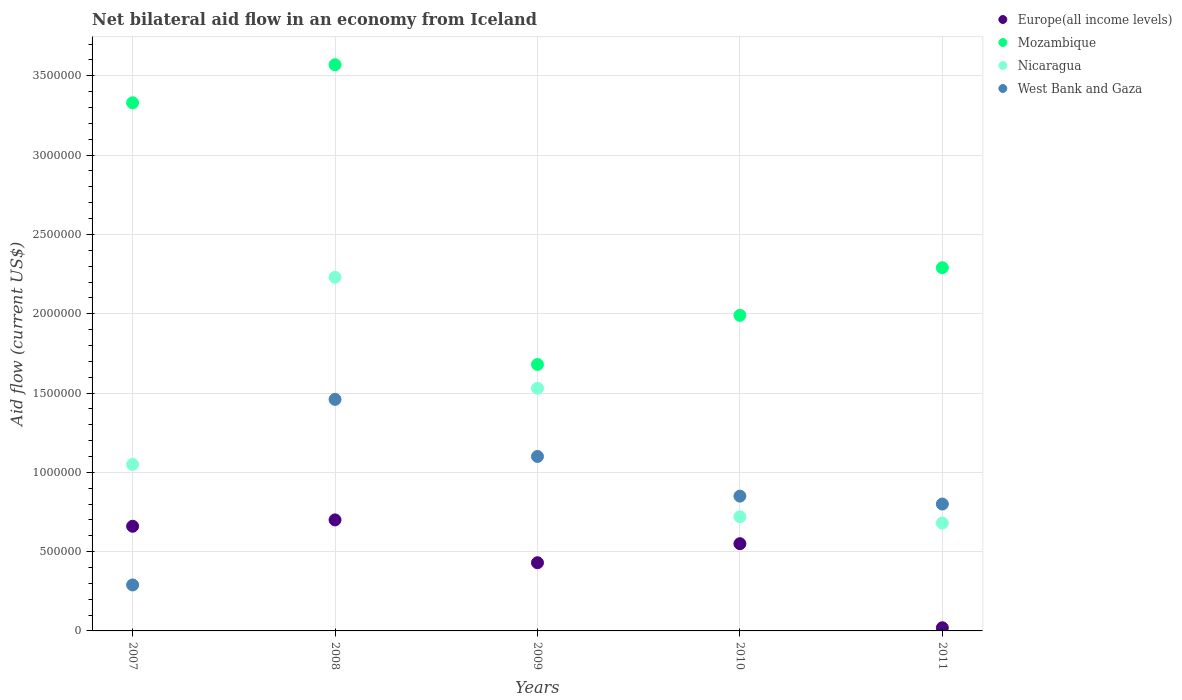What is the net bilateral aid flow in Nicaragua in 2008?
Make the answer very short. 2.23e+06. Across all years, what is the maximum net bilateral aid flow in Mozambique?
Provide a succinct answer. 3.57e+06. In which year was the net bilateral aid flow in West Bank and Gaza minimum?
Offer a terse response. 2007. What is the total net bilateral aid flow in Europe(all income levels) in the graph?
Your response must be concise. 2.36e+06. What is the difference between the net bilateral aid flow in Nicaragua in 2008 and that in 2010?
Provide a succinct answer. 1.51e+06. What is the difference between the net bilateral aid flow in West Bank and Gaza in 2011 and the net bilateral aid flow in Europe(all income levels) in 2010?
Provide a short and direct response. 2.50e+05. What is the average net bilateral aid flow in Europe(all income levels) per year?
Make the answer very short. 4.72e+05. In the year 2010, what is the difference between the net bilateral aid flow in West Bank and Gaza and net bilateral aid flow in Europe(all income levels)?
Give a very brief answer. 3.00e+05. In how many years, is the net bilateral aid flow in Europe(all income levels) greater than 3500000 US$?
Keep it short and to the point. 0. Is the difference between the net bilateral aid flow in West Bank and Gaza in 2007 and 2009 greater than the difference between the net bilateral aid flow in Europe(all income levels) in 2007 and 2009?
Keep it short and to the point. No. What is the difference between the highest and the second highest net bilateral aid flow in Nicaragua?
Offer a very short reply. 7.00e+05. What is the difference between the highest and the lowest net bilateral aid flow in Europe(all income levels)?
Ensure brevity in your answer.  6.80e+05. Is it the case that in every year, the sum of the net bilateral aid flow in Mozambique and net bilateral aid flow in Europe(all income levels)  is greater than the sum of net bilateral aid flow in West Bank and Gaza and net bilateral aid flow in Nicaragua?
Your answer should be very brief. Yes. Is the net bilateral aid flow in Europe(all income levels) strictly greater than the net bilateral aid flow in West Bank and Gaza over the years?
Ensure brevity in your answer.  No. Is the net bilateral aid flow in Nicaragua strictly less than the net bilateral aid flow in Mozambique over the years?
Offer a very short reply. Yes. How many dotlines are there?
Ensure brevity in your answer.  4. How many years are there in the graph?
Keep it short and to the point. 5. What is the difference between two consecutive major ticks on the Y-axis?
Your answer should be compact. 5.00e+05. Does the graph contain any zero values?
Give a very brief answer. No. Where does the legend appear in the graph?
Your answer should be compact. Top right. How many legend labels are there?
Ensure brevity in your answer.  4. How are the legend labels stacked?
Ensure brevity in your answer.  Vertical. What is the title of the graph?
Provide a short and direct response. Net bilateral aid flow in an economy from Iceland. What is the label or title of the Y-axis?
Provide a short and direct response. Aid flow (current US$). What is the Aid flow (current US$) of Mozambique in 2007?
Give a very brief answer. 3.33e+06. What is the Aid flow (current US$) in Nicaragua in 2007?
Your answer should be compact. 1.05e+06. What is the Aid flow (current US$) of West Bank and Gaza in 2007?
Make the answer very short. 2.90e+05. What is the Aid flow (current US$) in Mozambique in 2008?
Provide a succinct answer. 3.57e+06. What is the Aid flow (current US$) in Nicaragua in 2008?
Make the answer very short. 2.23e+06. What is the Aid flow (current US$) of West Bank and Gaza in 2008?
Your answer should be compact. 1.46e+06. What is the Aid flow (current US$) in Mozambique in 2009?
Provide a succinct answer. 1.68e+06. What is the Aid flow (current US$) in Nicaragua in 2009?
Offer a very short reply. 1.53e+06. What is the Aid flow (current US$) of West Bank and Gaza in 2009?
Your answer should be compact. 1.10e+06. What is the Aid flow (current US$) of Europe(all income levels) in 2010?
Make the answer very short. 5.50e+05. What is the Aid flow (current US$) in Mozambique in 2010?
Offer a terse response. 1.99e+06. What is the Aid flow (current US$) of Nicaragua in 2010?
Your answer should be compact. 7.20e+05. What is the Aid flow (current US$) in West Bank and Gaza in 2010?
Your response must be concise. 8.50e+05. What is the Aid flow (current US$) of Mozambique in 2011?
Make the answer very short. 2.29e+06. What is the Aid flow (current US$) of Nicaragua in 2011?
Provide a succinct answer. 6.80e+05. What is the Aid flow (current US$) of West Bank and Gaza in 2011?
Provide a short and direct response. 8.00e+05. Across all years, what is the maximum Aid flow (current US$) of Europe(all income levels)?
Give a very brief answer. 7.00e+05. Across all years, what is the maximum Aid flow (current US$) of Mozambique?
Your response must be concise. 3.57e+06. Across all years, what is the maximum Aid flow (current US$) in Nicaragua?
Offer a terse response. 2.23e+06. Across all years, what is the maximum Aid flow (current US$) of West Bank and Gaza?
Offer a very short reply. 1.46e+06. Across all years, what is the minimum Aid flow (current US$) in Mozambique?
Provide a succinct answer. 1.68e+06. Across all years, what is the minimum Aid flow (current US$) in Nicaragua?
Your response must be concise. 6.80e+05. Across all years, what is the minimum Aid flow (current US$) in West Bank and Gaza?
Keep it short and to the point. 2.90e+05. What is the total Aid flow (current US$) of Europe(all income levels) in the graph?
Give a very brief answer. 2.36e+06. What is the total Aid flow (current US$) in Mozambique in the graph?
Give a very brief answer. 1.29e+07. What is the total Aid flow (current US$) of Nicaragua in the graph?
Ensure brevity in your answer.  6.21e+06. What is the total Aid flow (current US$) of West Bank and Gaza in the graph?
Offer a terse response. 4.50e+06. What is the difference between the Aid flow (current US$) in Mozambique in 2007 and that in 2008?
Your answer should be compact. -2.40e+05. What is the difference between the Aid flow (current US$) in Nicaragua in 2007 and that in 2008?
Ensure brevity in your answer.  -1.18e+06. What is the difference between the Aid flow (current US$) in West Bank and Gaza in 2007 and that in 2008?
Offer a very short reply. -1.17e+06. What is the difference between the Aid flow (current US$) in Europe(all income levels) in 2007 and that in 2009?
Your response must be concise. 2.30e+05. What is the difference between the Aid flow (current US$) in Mozambique in 2007 and that in 2009?
Ensure brevity in your answer.  1.65e+06. What is the difference between the Aid flow (current US$) in Nicaragua in 2007 and that in 2009?
Your answer should be compact. -4.80e+05. What is the difference between the Aid flow (current US$) in West Bank and Gaza in 2007 and that in 2009?
Make the answer very short. -8.10e+05. What is the difference between the Aid flow (current US$) in Europe(all income levels) in 2007 and that in 2010?
Provide a succinct answer. 1.10e+05. What is the difference between the Aid flow (current US$) of Mozambique in 2007 and that in 2010?
Make the answer very short. 1.34e+06. What is the difference between the Aid flow (current US$) of West Bank and Gaza in 2007 and that in 2010?
Offer a very short reply. -5.60e+05. What is the difference between the Aid flow (current US$) in Europe(all income levels) in 2007 and that in 2011?
Offer a very short reply. 6.40e+05. What is the difference between the Aid flow (current US$) in Mozambique in 2007 and that in 2011?
Offer a terse response. 1.04e+06. What is the difference between the Aid flow (current US$) in Nicaragua in 2007 and that in 2011?
Keep it short and to the point. 3.70e+05. What is the difference between the Aid flow (current US$) in West Bank and Gaza in 2007 and that in 2011?
Make the answer very short. -5.10e+05. What is the difference between the Aid flow (current US$) in Mozambique in 2008 and that in 2009?
Offer a terse response. 1.89e+06. What is the difference between the Aid flow (current US$) of Mozambique in 2008 and that in 2010?
Provide a succinct answer. 1.58e+06. What is the difference between the Aid flow (current US$) of Nicaragua in 2008 and that in 2010?
Provide a short and direct response. 1.51e+06. What is the difference between the Aid flow (current US$) of West Bank and Gaza in 2008 and that in 2010?
Ensure brevity in your answer.  6.10e+05. What is the difference between the Aid flow (current US$) in Europe(all income levels) in 2008 and that in 2011?
Offer a very short reply. 6.80e+05. What is the difference between the Aid flow (current US$) in Mozambique in 2008 and that in 2011?
Ensure brevity in your answer.  1.28e+06. What is the difference between the Aid flow (current US$) of Nicaragua in 2008 and that in 2011?
Ensure brevity in your answer.  1.55e+06. What is the difference between the Aid flow (current US$) of West Bank and Gaza in 2008 and that in 2011?
Your answer should be compact. 6.60e+05. What is the difference between the Aid flow (current US$) in Mozambique in 2009 and that in 2010?
Give a very brief answer. -3.10e+05. What is the difference between the Aid flow (current US$) of Nicaragua in 2009 and that in 2010?
Provide a short and direct response. 8.10e+05. What is the difference between the Aid flow (current US$) of Mozambique in 2009 and that in 2011?
Provide a succinct answer. -6.10e+05. What is the difference between the Aid flow (current US$) in Nicaragua in 2009 and that in 2011?
Make the answer very short. 8.50e+05. What is the difference between the Aid flow (current US$) in West Bank and Gaza in 2009 and that in 2011?
Your answer should be very brief. 3.00e+05. What is the difference between the Aid flow (current US$) in Europe(all income levels) in 2010 and that in 2011?
Your answer should be very brief. 5.30e+05. What is the difference between the Aid flow (current US$) of Mozambique in 2010 and that in 2011?
Ensure brevity in your answer.  -3.00e+05. What is the difference between the Aid flow (current US$) in Nicaragua in 2010 and that in 2011?
Offer a very short reply. 4.00e+04. What is the difference between the Aid flow (current US$) in West Bank and Gaza in 2010 and that in 2011?
Offer a very short reply. 5.00e+04. What is the difference between the Aid flow (current US$) of Europe(all income levels) in 2007 and the Aid flow (current US$) of Mozambique in 2008?
Your answer should be very brief. -2.91e+06. What is the difference between the Aid flow (current US$) of Europe(all income levels) in 2007 and the Aid flow (current US$) of Nicaragua in 2008?
Your answer should be very brief. -1.57e+06. What is the difference between the Aid flow (current US$) of Europe(all income levels) in 2007 and the Aid flow (current US$) of West Bank and Gaza in 2008?
Offer a terse response. -8.00e+05. What is the difference between the Aid flow (current US$) of Mozambique in 2007 and the Aid flow (current US$) of Nicaragua in 2008?
Give a very brief answer. 1.10e+06. What is the difference between the Aid flow (current US$) in Mozambique in 2007 and the Aid flow (current US$) in West Bank and Gaza in 2008?
Your answer should be very brief. 1.87e+06. What is the difference between the Aid flow (current US$) of Nicaragua in 2007 and the Aid flow (current US$) of West Bank and Gaza in 2008?
Keep it short and to the point. -4.10e+05. What is the difference between the Aid flow (current US$) in Europe(all income levels) in 2007 and the Aid flow (current US$) in Mozambique in 2009?
Offer a very short reply. -1.02e+06. What is the difference between the Aid flow (current US$) of Europe(all income levels) in 2007 and the Aid flow (current US$) of Nicaragua in 2009?
Keep it short and to the point. -8.70e+05. What is the difference between the Aid flow (current US$) of Europe(all income levels) in 2007 and the Aid flow (current US$) of West Bank and Gaza in 2009?
Offer a terse response. -4.40e+05. What is the difference between the Aid flow (current US$) in Mozambique in 2007 and the Aid flow (current US$) in Nicaragua in 2009?
Your answer should be very brief. 1.80e+06. What is the difference between the Aid flow (current US$) of Mozambique in 2007 and the Aid flow (current US$) of West Bank and Gaza in 2009?
Your response must be concise. 2.23e+06. What is the difference between the Aid flow (current US$) in Europe(all income levels) in 2007 and the Aid flow (current US$) in Mozambique in 2010?
Keep it short and to the point. -1.33e+06. What is the difference between the Aid flow (current US$) of Europe(all income levels) in 2007 and the Aid flow (current US$) of West Bank and Gaza in 2010?
Make the answer very short. -1.90e+05. What is the difference between the Aid flow (current US$) of Mozambique in 2007 and the Aid flow (current US$) of Nicaragua in 2010?
Keep it short and to the point. 2.61e+06. What is the difference between the Aid flow (current US$) of Mozambique in 2007 and the Aid flow (current US$) of West Bank and Gaza in 2010?
Your answer should be very brief. 2.48e+06. What is the difference between the Aid flow (current US$) in Europe(all income levels) in 2007 and the Aid flow (current US$) in Mozambique in 2011?
Keep it short and to the point. -1.63e+06. What is the difference between the Aid flow (current US$) of Europe(all income levels) in 2007 and the Aid flow (current US$) of West Bank and Gaza in 2011?
Provide a succinct answer. -1.40e+05. What is the difference between the Aid flow (current US$) in Mozambique in 2007 and the Aid flow (current US$) in Nicaragua in 2011?
Give a very brief answer. 2.65e+06. What is the difference between the Aid flow (current US$) in Mozambique in 2007 and the Aid flow (current US$) in West Bank and Gaza in 2011?
Your answer should be very brief. 2.53e+06. What is the difference between the Aid flow (current US$) of Europe(all income levels) in 2008 and the Aid flow (current US$) of Mozambique in 2009?
Your response must be concise. -9.80e+05. What is the difference between the Aid flow (current US$) of Europe(all income levels) in 2008 and the Aid flow (current US$) of Nicaragua in 2009?
Offer a terse response. -8.30e+05. What is the difference between the Aid flow (current US$) in Europe(all income levels) in 2008 and the Aid flow (current US$) in West Bank and Gaza in 2009?
Give a very brief answer. -4.00e+05. What is the difference between the Aid flow (current US$) of Mozambique in 2008 and the Aid flow (current US$) of Nicaragua in 2009?
Ensure brevity in your answer.  2.04e+06. What is the difference between the Aid flow (current US$) in Mozambique in 2008 and the Aid flow (current US$) in West Bank and Gaza in 2009?
Provide a short and direct response. 2.47e+06. What is the difference between the Aid flow (current US$) of Nicaragua in 2008 and the Aid flow (current US$) of West Bank and Gaza in 2009?
Provide a succinct answer. 1.13e+06. What is the difference between the Aid flow (current US$) in Europe(all income levels) in 2008 and the Aid flow (current US$) in Mozambique in 2010?
Provide a succinct answer. -1.29e+06. What is the difference between the Aid flow (current US$) of Europe(all income levels) in 2008 and the Aid flow (current US$) of Nicaragua in 2010?
Give a very brief answer. -2.00e+04. What is the difference between the Aid flow (current US$) in Europe(all income levels) in 2008 and the Aid flow (current US$) in West Bank and Gaza in 2010?
Keep it short and to the point. -1.50e+05. What is the difference between the Aid flow (current US$) in Mozambique in 2008 and the Aid flow (current US$) in Nicaragua in 2010?
Provide a short and direct response. 2.85e+06. What is the difference between the Aid flow (current US$) of Mozambique in 2008 and the Aid flow (current US$) of West Bank and Gaza in 2010?
Offer a terse response. 2.72e+06. What is the difference between the Aid flow (current US$) of Nicaragua in 2008 and the Aid flow (current US$) of West Bank and Gaza in 2010?
Keep it short and to the point. 1.38e+06. What is the difference between the Aid flow (current US$) in Europe(all income levels) in 2008 and the Aid flow (current US$) in Mozambique in 2011?
Keep it short and to the point. -1.59e+06. What is the difference between the Aid flow (current US$) in Europe(all income levels) in 2008 and the Aid flow (current US$) in Nicaragua in 2011?
Offer a terse response. 2.00e+04. What is the difference between the Aid flow (current US$) of Europe(all income levels) in 2008 and the Aid flow (current US$) of West Bank and Gaza in 2011?
Provide a short and direct response. -1.00e+05. What is the difference between the Aid flow (current US$) in Mozambique in 2008 and the Aid flow (current US$) in Nicaragua in 2011?
Your answer should be compact. 2.89e+06. What is the difference between the Aid flow (current US$) in Mozambique in 2008 and the Aid flow (current US$) in West Bank and Gaza in 2011?
Your answer should be compact. 2.77e+06. What is the difference between the Aid flow (current US$) in Nicaragua in 2008 and the Aid flow (current US$) in West Bank and Gaza in 2011?
Offer a very short reply. 1.43e+06. What is the difference between the Aid flow (current US$) of Europe(all income levels) in 2009 and the Aid flow (current US$) of Mozambique in 2010?
Make the answer very short. -1.56e+06. What is the difference between the Aid flow (current US$) of Europe(all income levels) in 2009 and the Aid flow (current US$) of Nicaragua in 2010?
Provide a short and direct response. -2.90e+05. What is the difference between the Aid flow (current US$) of Europe(all income levels) in 2009 and the Aid flow (current US$) of West Bank and Gaza in 2010?
Keep it short and to the point. -4.20e+05. What is the difference between the Aid flow (current US$) of Mozambique in 2009 and the Aid flow (current US$) of Nicaragua in 2010?
Make the answer very short. 9.60e+05. What is the difference between the Aid flow (current US$) in Mozambique in 2009 and the Aid flow (current US$) in West Bank and Gaza in 2010?
Your response must be concise. 8.30e+05. What is the difference between the Aid flow (current US$) in Nicaragua in 2009 and the Aid flow (current US$) in West Bank and Gaza in 2010?
Ensure brevity in your answer.  6.80e+05. What is the difference between the Aid flow (current US$) of Europe(all income levels) in 2009 and the Aid flow (current US$) of Mozambique in 2011?
Offer a very short reply. -1.86e+06. What is the difference between the Aid flow (current US$) in Europe(all income levels) in 2009 and the Aid flow (current US$) in Nicaragua in 2011?
Provide a short and direct response. -2.50e+05. What is the difference between the Aid flow (current US$) in Europe(all income levels) in 2009 and the Aid flow (current US$) in West Bank and Gaza in 2011?
Ensure brevity in your answer.  -3.70e+05. What is the difference between the Aid flow (current US$) in Mozambique in 2009 and the Aid flow (current US$) in West Bank and Gaza in 2011?
Your answer should be compact. 8.80e+05. What is the difference between the Aid flow (current US$) of Nicaragua in 2009 and the Aid flow (current US$) of West Bank and Gaza in 2011?
Give a very brief answer. 7.30e+05. What is the difference between the Aid flow (current US$) in Europe(all income levels) in 2010 and the Aid flow (current US$) in Mozambique in 2011?
Your response must be concise. -1.74e+06. What is the difference between the Aid flow (current US$) in Mozambique in 2010 and the Aid flow (current US$) in Nicaragua in 2011?
Keep it short and to the point. 1.31e+06. What is the difference between the Aid flow (current US$) in Mozambique in 2010 and the Aid flow (current US$) in West Bank and Gaza in 2011?
Offer a very short reply. 1.19e+06. What is the difference between the Aid flow (current US$) of Nicaragua in 2010 and the Aid flow (current US$) of West Bank and Gaza in 2011?
Your answer should be compact. -8.00e+04. What is the average Aid flow (current US$) in Europe(all income levels) per year?
Keep it short and to the point. 4.72e+05. What is the average Aid flow (current US$) of Mozambique per year?
Ensure brevity in your answer.  2.57e+06. What is the average Aid flow (current US$) in Nicaragua per year?
Ensure brevity in your answer.  1.24e+06. What is the average Aid flow (current US$) of West Bank and Gaza per year?
Offer a terse response. 9.00e+05. In the year 2007, what is the difference between the Aid flow (current US$) of Europe(all income levels) and Aid flow (current US$) of Mozambique?
Ensure brevity in your answer.  -2.67e+06. In the year 2007, what is the difference between the Aid flow (current US$) in Europe(all income levels) and Aid flow (current US$) in Nicaragua?
Give a very brief answer. -3.90e+05. In the year 2007, what is the difference between the Aid flow (current US$) in Mozambique and Aid flow (current US$) in Nicaragua?
Your answer should be compact. 2.28e+06. In the year 2007, what is the difference between the Aid flow (current US$) of Mozambique and Aid flow (current US$) of West Bank and Gaza?
Give a very brief answer. 3.04e+06. In the year 2007, what is the difference between the Aid flow (current US$) of Nicaragua and Aid flow (current US$) of West Bank and Gaza?
Offer a terse response. 7.60e+05. In the year 2008, what is the difference between the Aid flow (current US$) of Europe(all income levels) and Aid flow (current US$) of Mozambique?
Your answer should be compact. -2.87e+06. In the year 2008, what is the difference between the Aid flow (current US$) of Europe(all income levels) and Aid flow (current US$) of Nicaragua?
Give a very brief answer. -1.53e+06. In the year 2008, what is the difference between the Aid flow (current US$) of Europe(all income levels) and Aid flow (current US$) of West Bank and Gaza?
Make the answer very short. -7.60e+05. In the year 2008, what is the difference between the Aid flow (current US$) in Mozambique and Aid flow (current US$) in Nicaragua?
Give a very brief answer. 1.34e+06. In the year 2008, what is the difference between the Aid flow (current US$) in Mozambique and Aid flow (current US$) in West Bank and Gaza?
Provide a short and direct response. 2.11e+06. In the year 2008, what is the difference between the Aid flow (current US$) in Nicaragua and Aid flow (current US$) in West Bank and Gaza?
Make the answer very short. 7.70e+05. In the year 2009, what is the difference between the Aid flow (current US$) in Europe(all income levels) and Aid flow (current US$) in Mozambique?
Your response must be concise. -1.25e+06. In the year 2009, what is the difference between the Aid flow (current US$) in Europe(all income levels) and Aid flow (current US$) in Nicaragua?
Ensure brevity in your answer.  -1.10e+06. In the year 2009, what is the difference between the Aid flow (current US$) of Europe(all income levels) and Aid flow (current US$) of West Bank and Gaza?
Your response must be concise. -6.70e+05. In the year 2009, what is the difference between the Aid flow (current US$) in Mozambique and Aid flow (current US$) in West Bank and Gaza?
Ensure brevity in your answer.  5.80e+05. In the year 2009, what is the difference between the Aid flow (current US$) in Nicaragua and Aid flow (current US$) in West Bank and Gaza?
Offer a very short reply. 4.30e+05. In the year 2010, what is the difference between the Aid flow (current US$) in Europe(all income levels) and Aid flow (current US$) in Mozambique?
Make the answer very short. -1.44e+06. In the year 2010, what is the difference between the Aid flow (current US$) in Mozambique and Aid flow (current US$) in Nicaragua?
Offer a terse response. 1.27e+06. In the year 2010, what is the difference between the Aid flow (current US$) of Mozambique and Aid flow (current US$) of West Bank and Gaza?
Ensure brevity in your answer.  1.14e+06. In the year 2010, what is the difference between the Aid flow (current US$) of Nicaragua and Aid flow (current US$) of West Bank and Gaza?
Ensure brevity in your answer.  -1.30e+05. In the year 2011, what is the difference between the Aid flow (current US$) in Europe(all income levels) and Aid flow (current US$) in Mozambique?
Give a very brief answer. -2.27e+06. In the year 2011, what is the difference between the Aid flow (current US$) in Europe(all income levels) and Aid flow (current US$) in Nicaragua?
Give a very brief answer. -6.60e+05. In the year 2011, what is the difference between the Aid flow (current US$) of Europe(all income levels) and Aid flow (current US$) of West Bank and Gaza?
Ensure brevity in your answer.  -7.80e+05. In the year 2011, what is the difference between the Aid flow (current US$) of Mozambique and Aid flow (current US$) of Nicaragua?
Give a very brief answer. 1.61e+06. In the year 2011, what is the difference between the Aid flow (current US$) in Mozambique and Aid flow (current US$) in West Bank and Gaza?
Your response must be concise. 1.49e+06. In the year 2011, what is the difference between the Aid flow (current US$) of Nicaragua and Aid flow (current US$) of West Bank and Gaza?
Your answer should be compact. -1.20e+05. What is the ratio of the Aid flow (current US$) of Europe(all income levels) in 2007 to that in 2008?
Offer a very short reply. 0.94. What is the ratio of the Aid flow (current US$) of Mozambique in 2007 to that in 2008?
Ensure brevity in your answer.  0.93. What is the ratio of the Aid flow (current US$) in Nicaragua in 2007 to that in 2008?
Keep it short and to the point. 0.47. What is the ratio of the Aid flow (current US$) of West Bank and Gaza in 2007 to that in 2008?
Keep it short and to the point. 0.2. What is the ratio of the Aid flow (current US$) of Europe(all income levels) in 2007 to that in 2009?
Keep it short and to the point. 1.53. What is the ratio of the Aid flow (current US$) in Mozambique in 2007 to that in 2009?
Your answer should be compact. 1.98. What is the ratio of the Aid flow (current US$) of Nicaragua in 2007 to that in 2009?
Your response must be concise. 0.69. What is the ratio of the Aid flow (current US$) of West Bank and Gaza in 2007 to that in 2009?
Your answer should be very brief. 0.26. What is the ratio of the Aid flow (current US$) of Europe(all income levels) in 2007 to that in 2010?
Keep it short and to the point. 1.2. What is the ratio of the Aid flow (current US$) in Mozambique in 2007 to that in 2010?
Offer a terse response. 1.67. What is the ratio of the Aid flow (current US$) in Nicaragua in 2007 to that in 2010?
Ensure brevity in your answer.  1.46. What is the ratio of the Aid flow (current US$) of West Bank and Gaza in 2007 to that in 2010?
Your response must be concise. 0.34. What is the ratio of the Aid flow (current US$) in Mozambique in 2007 to that in 2011?
Provide a succinct answer. 1.45. What is the ratio of the Aid flow (current US$) in Nicaragua in 2007 to that in 2011?
Give a very brief answer. 1.54. What is the ratio of the Aid flow (current US$) of West Bank and Gaza in 2007 to that in 2011?
Give a very brief answer. 0.36. What is the ratio of the Aid flow (current US$) in Europe(all income levels) in 2008 to that in 2009?
Ensure brevity in your answer.  1.63. What is the ratio of the Aid flow (current US$) in Mozambique in 2008 to that in 2009?
Provide a short and direct response. 2.12. What is the ratio of the Aid flow (current US$) of Nicaragua in 2008 to that in 2009?
Offer a very short reply. 1.46. What is the ratio of the Aid flow (current US$) of West Bank and Gaza in 2008 to that in 2009?
Make the answer very short. 1.33. What is the ratio of the Aid flow (current US$) of Europe(all income levels) in 2008 to that in 2010?
Make the answer very short. 1.27. What is the ratio of the Aid flow (current US$) of Mozambique in 2008 to that in 2010?
Keep it short and to the point. 1.79. What is the ratio of the Aid flow (current US$) in Nicaragua in 2008 to that in 2010?
Your answer should be very brief. 3.1. What is the ratio of the Aid flow (current US$) in West Bank and Gaza in 2008 to that in 2010?
Provide a short and direct response. 1.72. What is the ratio of the Aid flow (current US$) in Mozambique in 2008 to that in 2011?
Your answer should be very brief. 1.56. What is the ratio of the Aid flow (current US$) of Nicaragua in 2008 to that in 2011?
Give a very brief answer. 3.28. What is the ratio of the Aid flow (current US$) in West Bank and Gaza in 2008 to that in 2011?
Make the answer very short. 1.82. What is the ratio of the Aid flow (current US$) of Europe(all income levels) in 2009 to that in 2010?
Keep it short and to the point. 0.78. What is the ratio of the Aid flow (current US$) of Mozambique in 2009 to that in 2010?
Give a very brief answer. 0.84. What is the ratio of the Aid flow (current US$) of Nicaragua in 2009 to that in 2010?
Give a very brief answer. 2.12. What is the ratio of the Aid flow (current US$) of West Bank and Gaza in 2009 to that in 2010?
Your answer should be very brief. 1.29. What is the ratio of the Aid flow (current US$) of Mozambique in 2009 to that in 2011?
Keep it short and to the point. 0.73. What is the ratio of the Aid flow (current US$) in Nicaragua in 2009 to that in 2011?
Give a very brief answer. 2.25. What is the ratio of the Aid flow (current US$) of West Bank and Gaza in 2009 to that in 2011?
Provide a succinct answer. 1.38. What is the ratio of the Aid flow (current US$) in Europe(all income levels) in 2010 to that in 2011?
Offer a very short reply. 27.5. What is the ratio of the Aid flow (current US$) of Mozambique in 2010 to that in 2011?
Provide a succinct answer. 0.87. What is the ratio of the Aid flow (current US$) of Nicaragua in 2010 to that in 2011?
Keep it short and to the point. 1.06. What is the difference between the highest and the second highest Aid flow (current US$) in Mozambique?
Make the answer very short. 2.40e+05. What is the difference between the highest and the second highest Aid flow (current US$) of Nicaragua?
Provide a succinct answer. 7.00e+05. What is the difference between the highest and the second highest Aid flow (current US$) in West Bank and Gaza?
Your answer should be very brief. 3.60e+05. What is the difference between the highest and the lowest Aid flow (current US$) in Europe(all income levels)?
Your answer should be very brief. 6.80e+05. What is the difference between the highest and the lowest Aid flow (current US$) of Mozambique?
Your answer should be very brief. 1.89e+06. What is the difference between the highest and the lowest Aid flow (current US$) in Nicaragua?
Provide a short and direct response. 1.55e+06. What is the difference between the highest and the lowest Aid flow (current US$) in West Bank and Gaza?
Ensure brevity in your answer.  1.17e+06. 